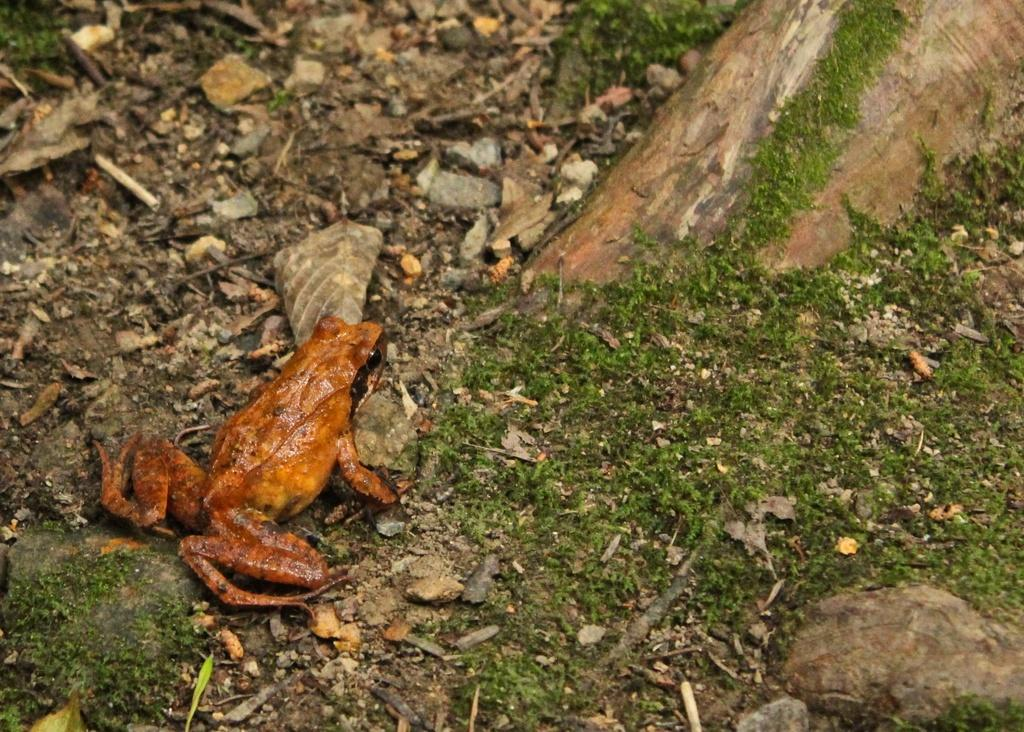What is the main subject of the image? There is a frog on the surface in the image. What objects are near the frog? There are stones and dry leaves beside the frog. What natural element is in front of the frog? The root of a tree is in front of the frog. How many corks can be seen floating in the water near the frog? There is no water or corks present in the image; it features a frog, stones, dry leaves, and a tree root. 